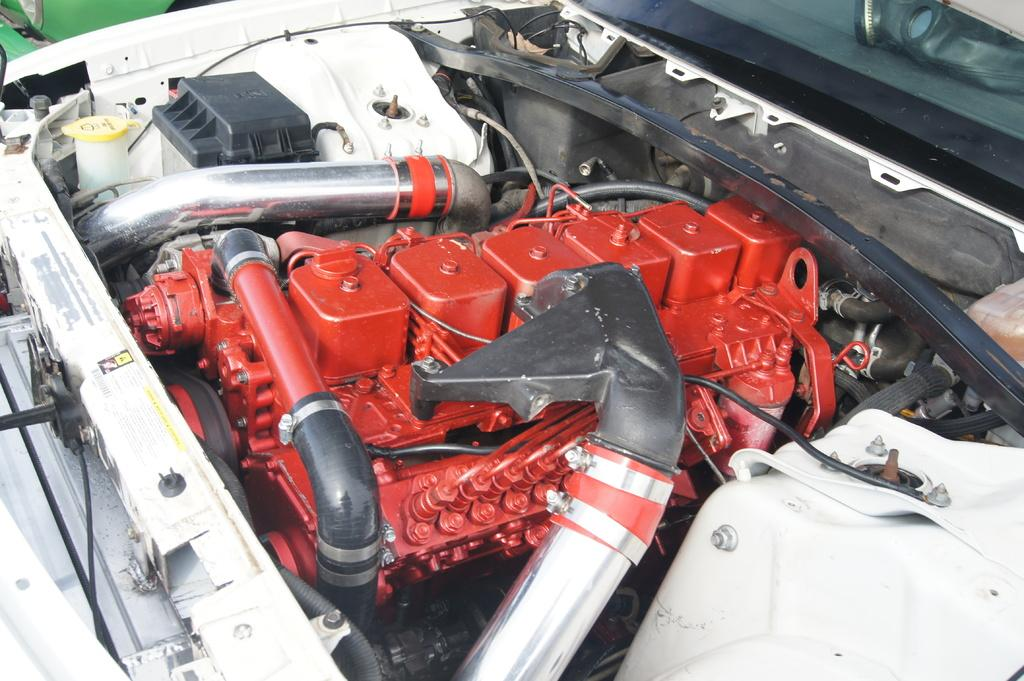What is the main subject of the image? The main subject of the image is a vehicle engine. How many fans are visible in the image? There are no fans present in the image, as it features a vehicle engine. What type of drawer can be seen in the image? There is no drawer present in the image, as it features a vehicle engine. 